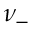<formula> <loc_0><loc_0><loc_500><loc_500>\nu _ { - }</formula> 